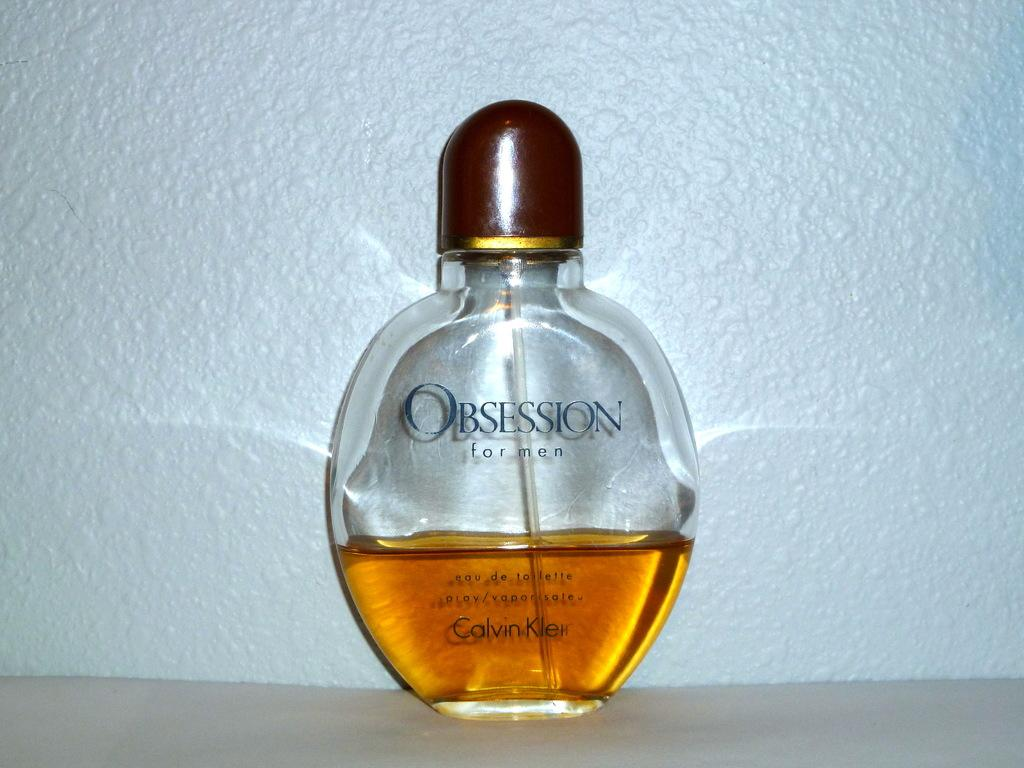<image>
Create a compact narrative representing the image presented. a half full bottle of obsession branded perfume with a white background. 